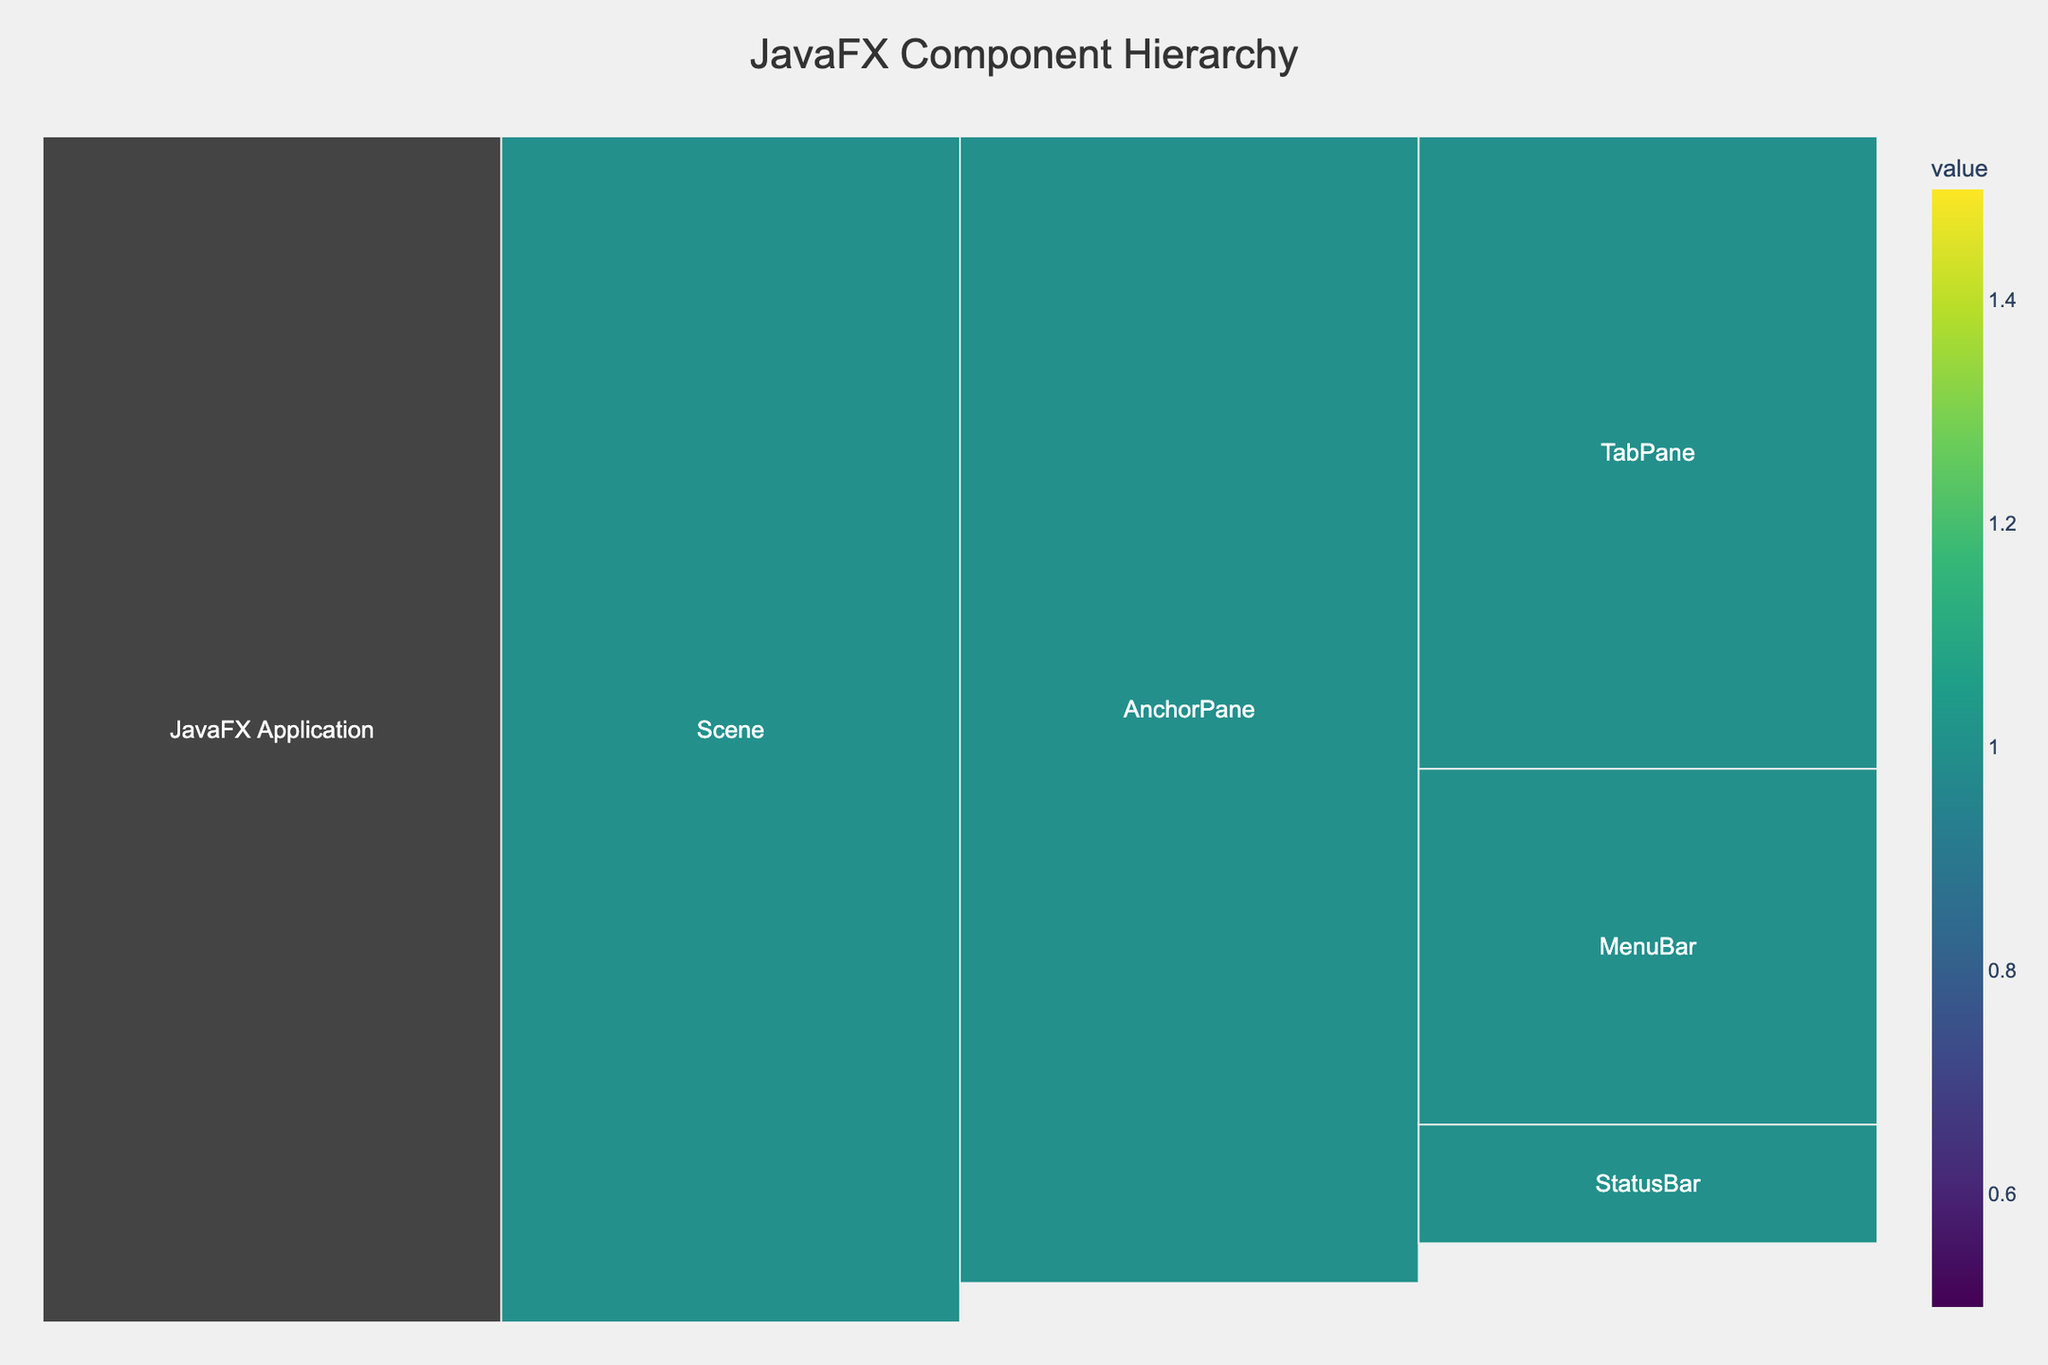What's the title of the Icicle Chart? The title is prominently displayed at the top of the chart. The chart's title is "JavaFX Component Hierarchy," indicating that it visualizes the hierarchical structure of JavaFX components.
Answer: JavaFX Component Hierarchy How many primary categories are there under the "AnchorPane" node? Look at the "AnchorPane" node in the chart. It has three primary categories connected to it: "MenuBar," "TabPane," and "StatusBar."
Answer: 3 Which component comes directly under the "StatusBar" node? In the Icicle Chart, two components are directly under the "StatusBar" node. They are "ProgressBar" and "Label."
Answer: ProgressBar and Label What's the total number of child nodes under the "TabPane" node? The "TabPane" node has three immediate child nodes: "Controls Tab," "Layouts Tab," and "Charts Tab." Each of these tabs has its own child nodes. Counting them all gives: Controls Tab (5) + Layouts Tab (4) + Charts Tab (3) = 12.
Answer: 12 Which "MenuBar" category has the most child nodes? By examining the "MenuBar" node, we see four categories: "File," "Edit," "View," and "Help." Among these, "File" has the most child nodes, with four (New, Open, Save, Exit).
Answer: File Are there more nodes under "Layouts Tab" or "Charts Tab"? The "Layouts Tab" node has four child nodes (VBox, HBox, GridPane, BorderPane), whereas the "Charts Tab" node has three child nodes (PieChart, BarChart, LineChart). Thus, "Layouts Tab" has more nodes.
Answer: Layouts Tab What is the immediate parent of the "PieChart" node? By following the hierarchy, the immediate parent of the "PieChart" node is the "Charts Tab."
Answer: Charts Tab How many second-level categories (nodes connected directly to "root") are there in the chart? The chart shows one node connected directly to the "root": the "JavaFX Application." Thus, there is only one second-level category.
Answer: 1 Which child node under "File" might indicate an exit option for the application? Under the "File" node, the child node labeled "Exit" likely represents an option to close or exit the application.
Answer: Exit Does "Button" belong to "Controls Tab" or "Layouts Tab"? The "Button" node is a child directly under the "Controls Tab," indicating it belongs to the "Controls Tab" category.
Answer: Controls Tab 